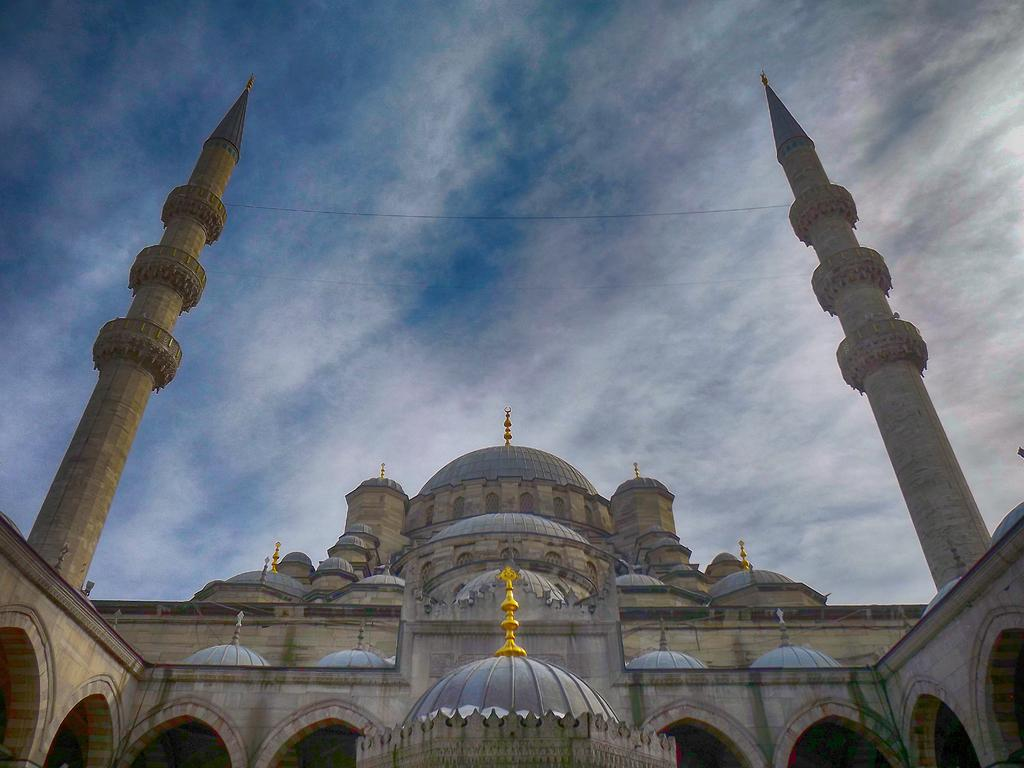What type of architecture is depicted in the image? The image contains ancient architecture. What structural elements can be seen in the image? Walls and pillars are visible in the image. What can be seen in the background of the image? The sky is visible in the background of the image. What type of surprise can be seen in the image? There is no surprise present in the image; it features ancient architecture with walls and pillars. What kind of toy is being used by the ancient civilization in the image? There is no toy present in the image; it depicts ancient architecture with walls and pillars. 